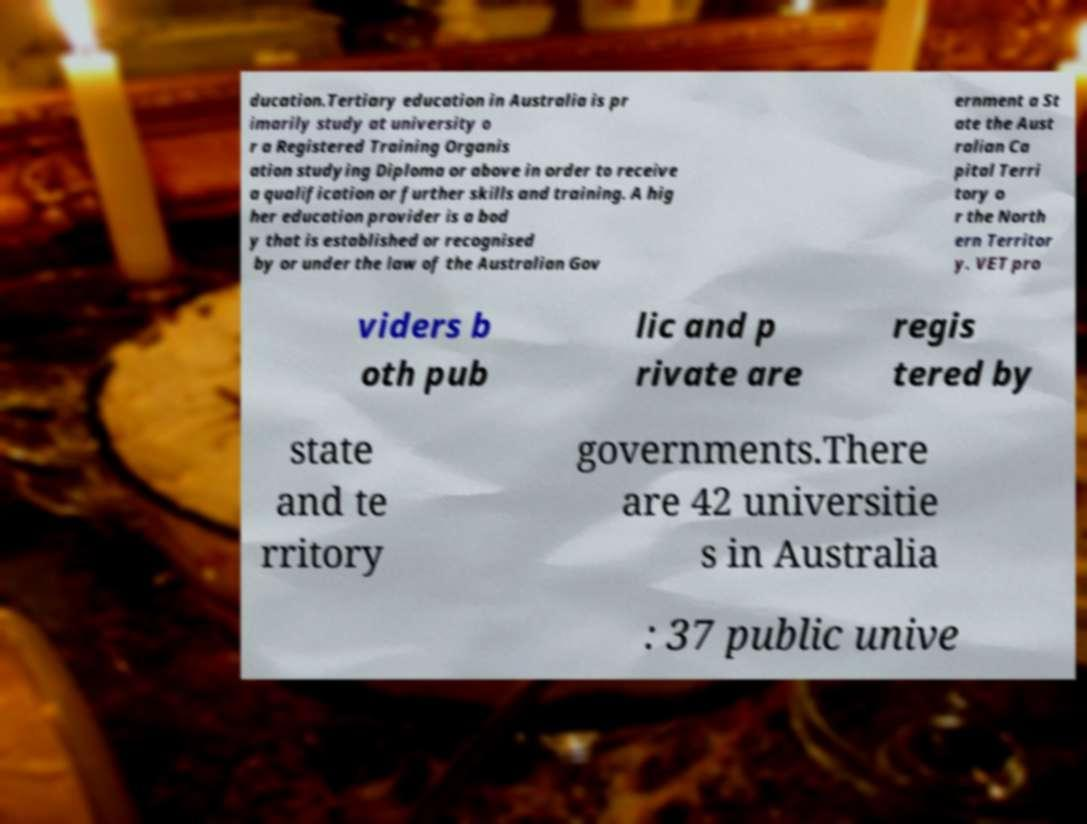There's text embedded in this image that I need extracted. Can you transcribe it verbatim? ducation.Tertiary education in Australia is pr imarily study at university o r a Registered Training Organis ation studying Diploma or above in order to receive a qualification or further skills and training. A hig her education provider is a bod y that is established or recognised by or under the law of the Australian Gov ernment a St ate the Aust ralian Ca pital Terri tory o r the North ern Territor y. VET pro viders b oth pub lic and p rivate are regis tered by state and te rritory governments.There are 42 universitie s in Australia : 37 public unive 